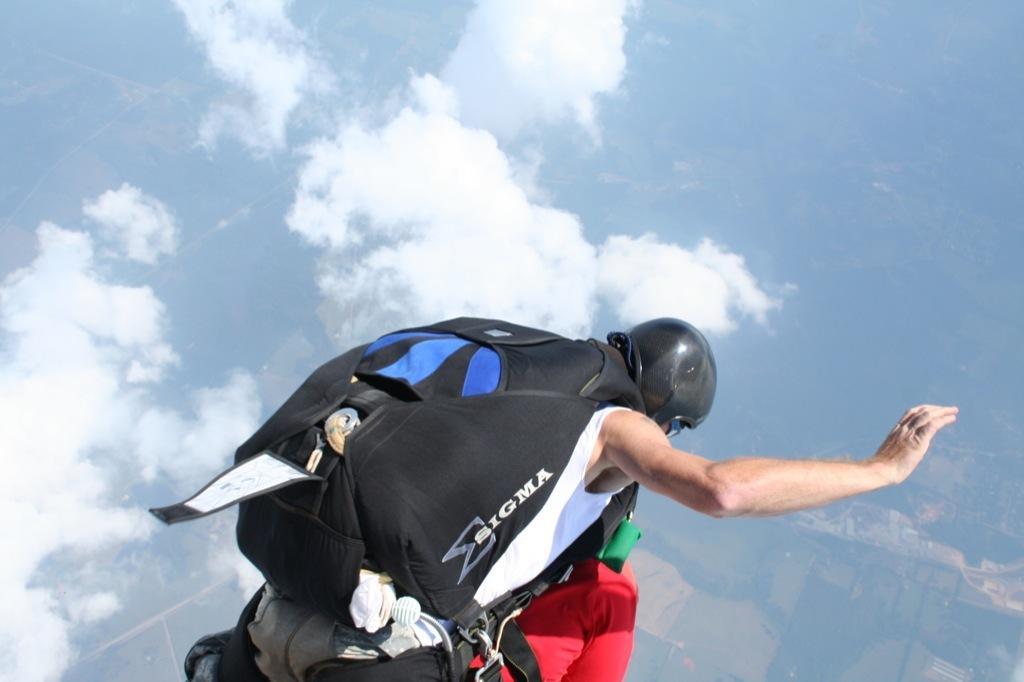Describe this image in one or two sentences. In this image I can see a person skydiving, wearing a bag and there are clouds in the sky. 